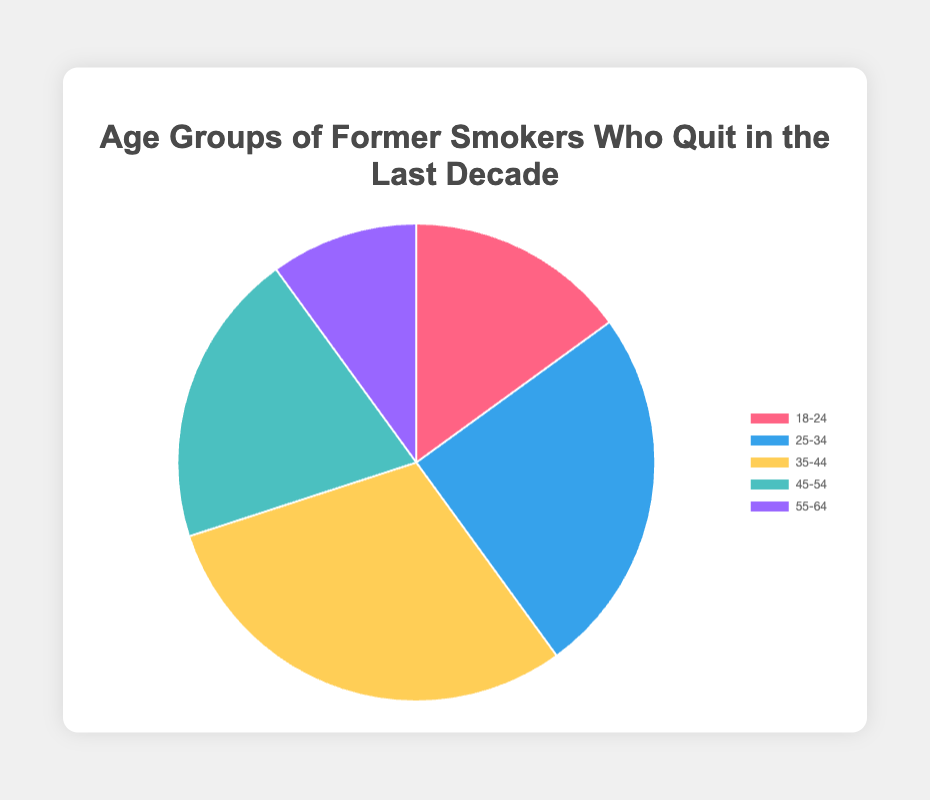What percentage of former smokers are within the 35-44 age range? The pie chart visually represents the data, showing that the 35-44 age range occupies 30% of the pie.
Answer: 30% Which age group has the smallest percentage of former smokers? By examining the size of each segment in the pie chart, it's evident that the smallest segment belongs to the 55-64 age range, which has 10%.
Answer: 55-64 What is the combined percentage of former smokers in the 25-34 and 45-54 age ranges? To find the combined percentage, I add the percentages of the 25-34 and 45-54 age ranges: 25% + 20% = 45%.
Answer: 45% Which two age groups together account for half of the former smokers? Considering the percentages, I need to find two age groups whose combined percentage is 50%. The 18-24 age group (15%) and the 35-44 age group (30%) combined with the 55-64 age group (10%) equal 55%, but the closest is the 25-34 (25%) and 45-54 (20%) together equal 45%. The closest is the sum of age groups 25-34 and 45-54 (45%).
Answer: 25-34 and 45-54 Which segment is represented by the color blue? The chart uses blue to represent the 25-34 age range as it appears in the second position of the color array.
Answer: 25-34 What is the percentage difference between the age groups 18-24 and 55-64? The 18-24 age group is represented by 15% and the 55-64 age group by 10%. The percentage difference is calculated as 15% - 10% = 5%.
Answer: 5% Which age group has a percentage twice that of the 55-64 age range? The 55-64 age range is 10%, so I need an age group with 20%. The 45-54 age range fits this requirement with 20%.
Answer: 45-54 What's the sum of the percentages for the 18-24 and 45-54 age groups? The percentages for the 18-24 and 45-54 age groups are 15% and 20%, respectively. Their sum is 15% + 20% = 35%.
Answer: 35% Which age group has the second largest percentage? By comparing the sizes of the segments, I determine that the 25-34 age group is the second largest with 25%, following the largest, 35-44 with 30%.
Answer: 25-34 